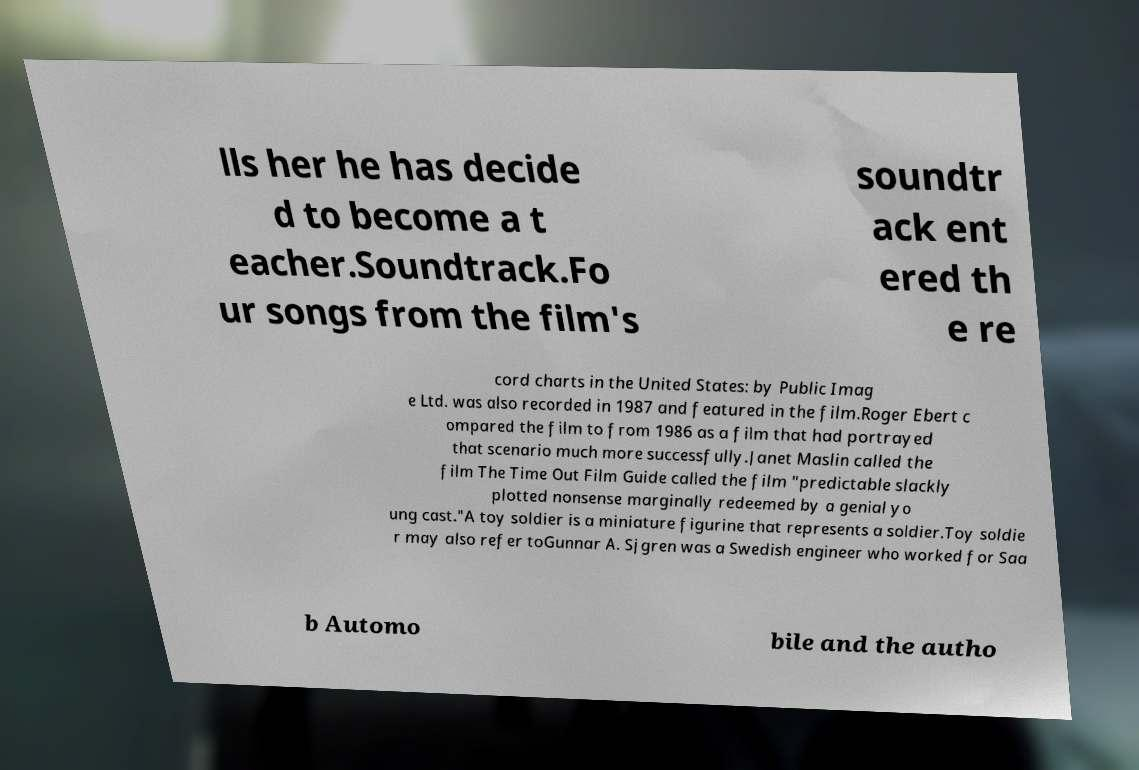Please read and relay the text visible in this image. What does it say? lls her he has decide d to become a t eacher.Soundtrack.Fo ur songs from the film's soundtr ack ent ered th e re cord charts in the United States: by Public Imag e Ltd. was also recorded in 1987 and featured in the film.Roger Ebert c ompared the film to from 1986 as a film that had portrayed that scenario much more successfully.Janet Maslin called the film The Time Out Film Guide called the film "predictable slackly plotted nonsense marginally redeemed by a genial yo ung cast."A toy soldier is a miniature figurine that represents a soldier.Toy soldie r may also refer toGunnar A. Sjgren was a Swedish engineer who worked for Saa b Automo bile and the autho 